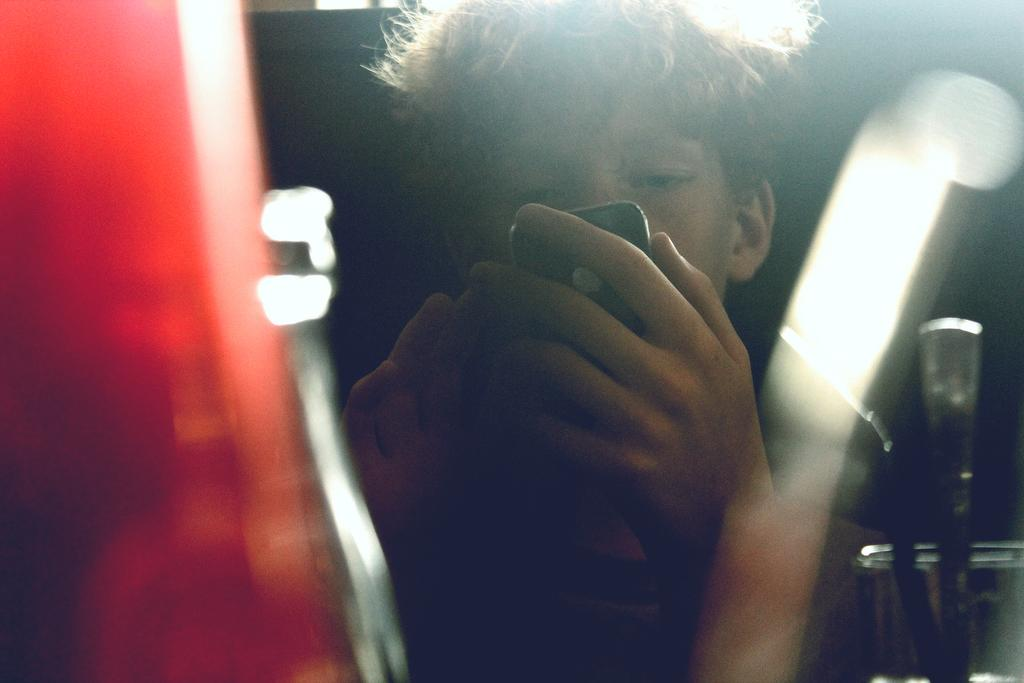What is the person in the image doing? The person is sitting in the image. What object is the person holding? The person is holding a mobile. What other objects can be seen in the image? There is a glass and a spoon in the image. Can you describe the background of the image? The background of the image is blurry. What scientific experiment is being conducted in the image? There is no scientific experiment present in the image. What type of shade is covering the person in the image? There is no shade covering the person in the image. 